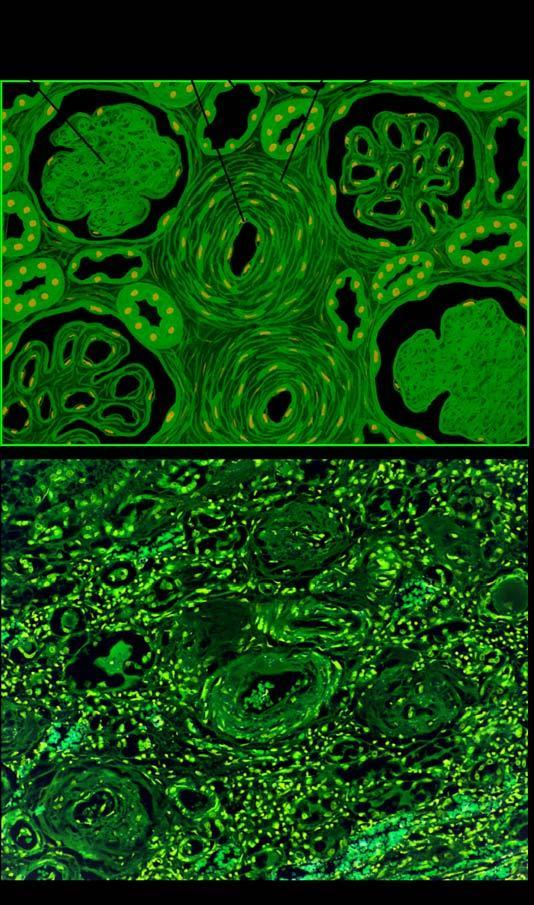do liver cells include sclerosed glomeruli, tubular atrophy and fine interstitial fibrosis?
Answer the question using a single word or phrase. No 